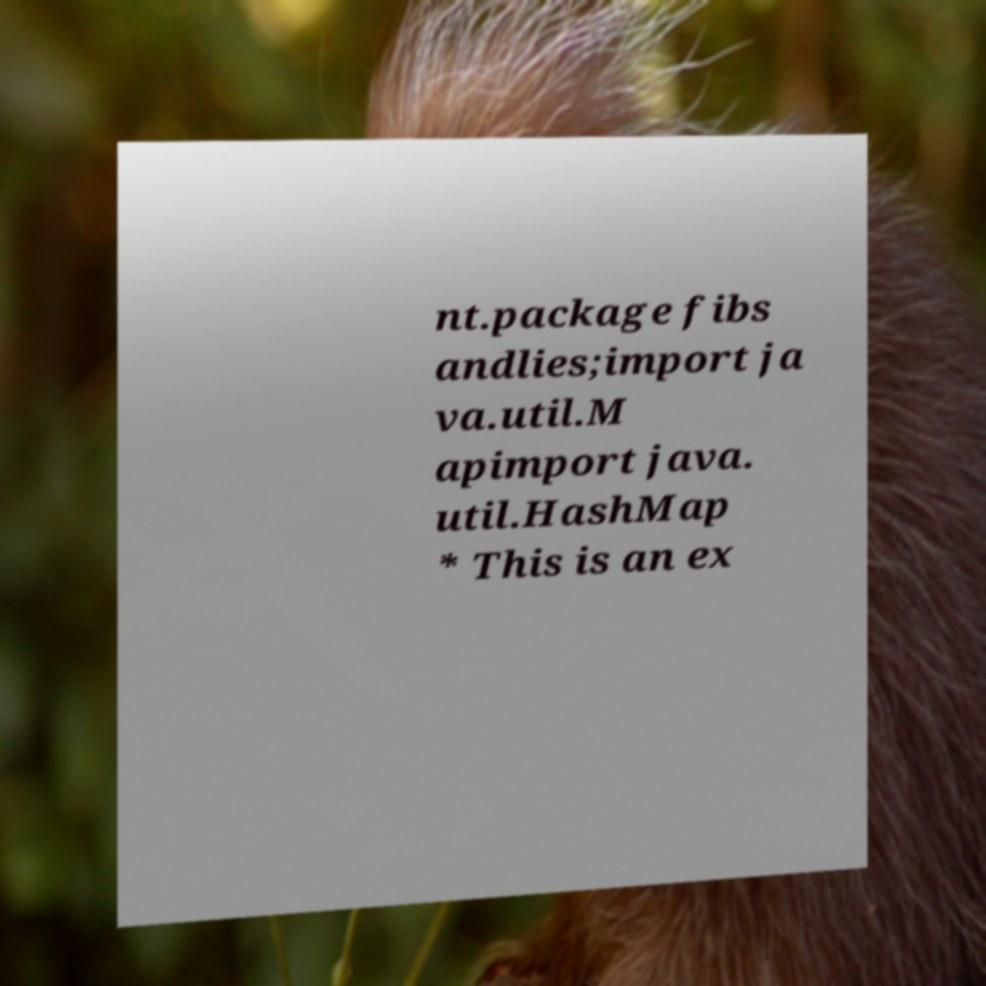Could you assist in decoding the text presented in this image and type it out clearly? nt.package fibs andlies;import ja va.util.M apimport java. util.HashMap * This is an ex 